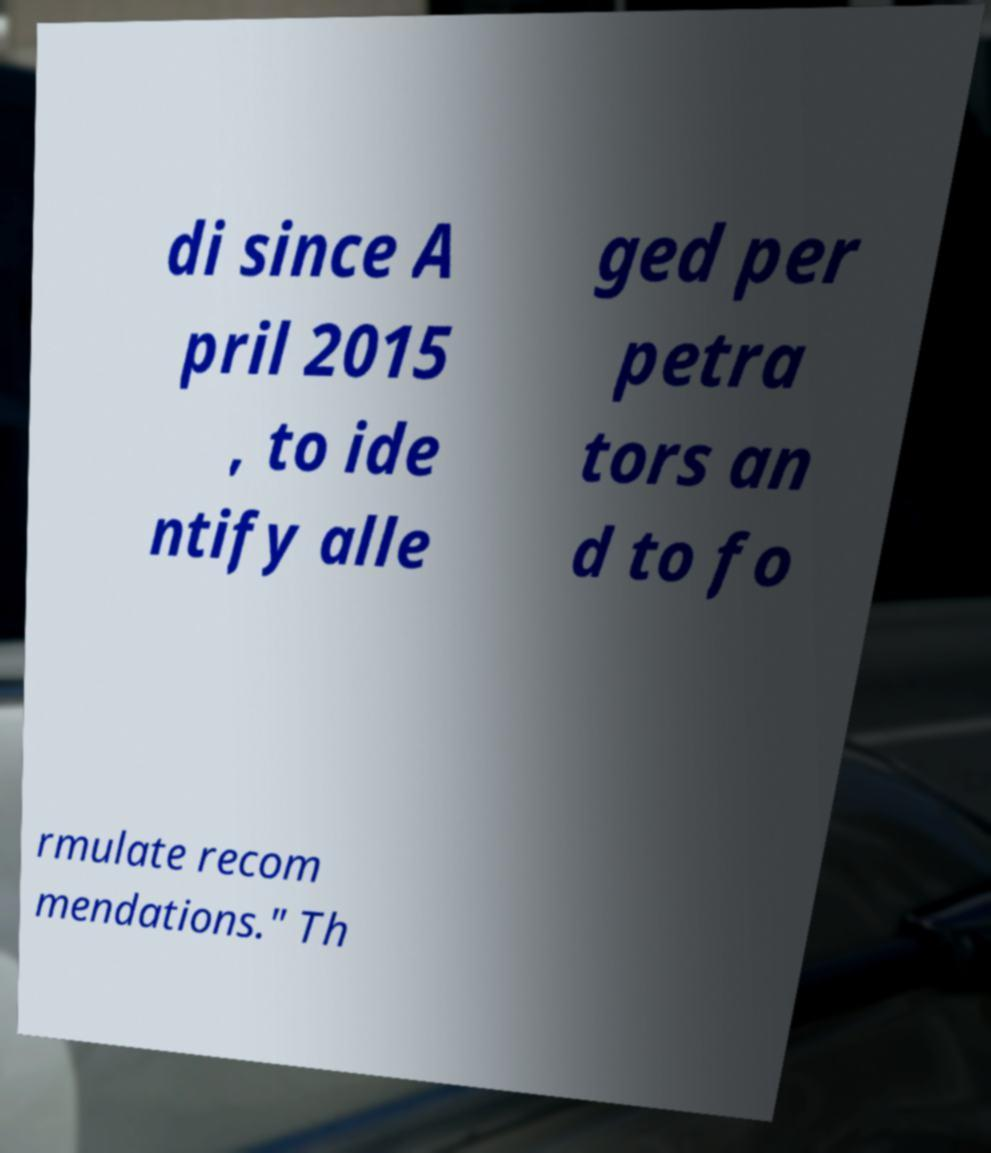Could you extract and type out the text from this image? di since A pril 2015 , to ide ntify alle ged per petra tors an d to fo rmulate recom mendations." Th 